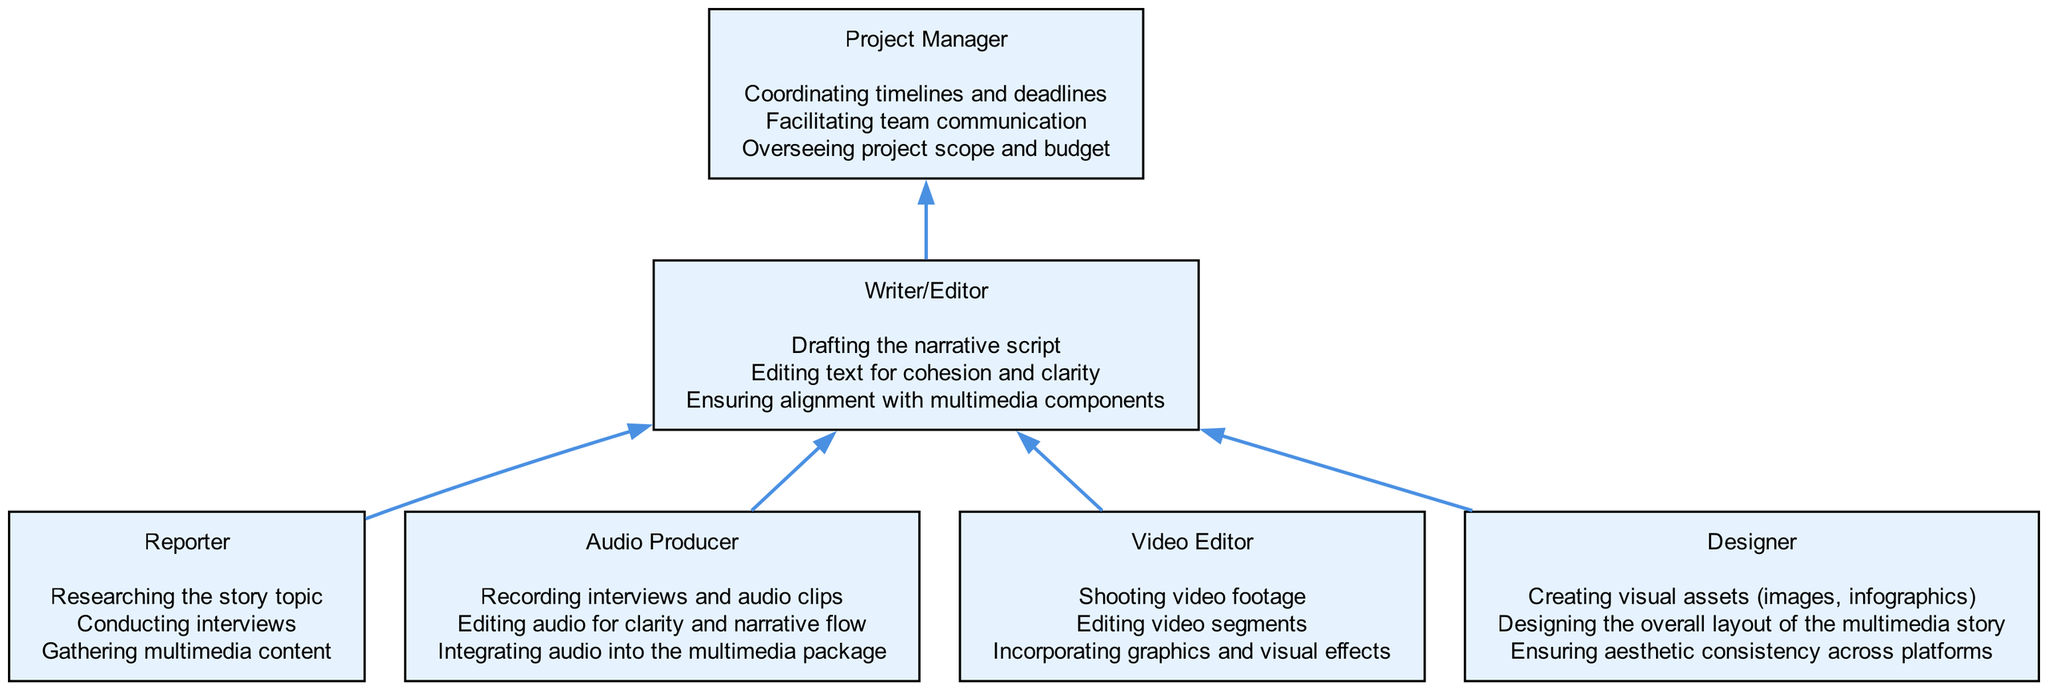What is the final node in the workflow? The final node in the workflow is the Project Manager. This is determined by tracing the flow upward through the diagram, where the Writer/Editor connects to the Project Manager as the last step in the process.
Answer: Project Manager How many distinct team members are involved in the project? There are six distinct team members involved in the project. Each member is represented as a separate node in the diagram, including Reporter, Audio Producer, Video Editor, Writer/Editor, Designer, and Project Manager.
Answer: 6 Which role is responsible for editing audio? The role responsible for editing audio is the Audio Producer, as indicated in their listed responsibilities which specifically mention editing audio for clarity and narrative flow.
Answer: Audio Producer Who does the Writer/Editor directly connect to? The Writer/Editor directly connects to the Project Manager as the final step in the workflow. There are also incoming connections from Reporter, Audio Producer, Video Editor, and Designer leading to the Writer/Editor.
Answer: Project Manager What is the primary responsibility of the Designer? The primary responsibility of the Designer includes creating visual assets, as stated in their responsibilities, which highlight the importance of visual content creation for the multimedia story.
Answer: Creating visual assets (images, infographics) Which node has the most incoming connections? The Writer/Editor has the most incoming connections, receiving input from four different roles: Reporter, Audio Producer, Video Editor, and Designer, showcasing its central role in the workflow.
Answer: Writer/Editor What task does the Project Manager handle? The Project Manager handles coordinating timelines and deadlines, as mentioned in their responsibilities, which is crucial for keeping the project on track.
Answer: Coordinating timelines and deadlines How does the Audio Producer contribute to the project? The Audio Producer contributes to the project by recording interviews and audio clips, as well as editing audio, which directly supports the overall multimedia storytelling effort.
Answer: Recording interviews and audio clips Which two roles lead to the Writer/Editor? The two roles that lead to the Writer/Editor, indicated by the connecting edges, are the Audio Producer and Video Editor, both of which provide essential content for the narrative.
Answer: Audio Producer and Video Editor 